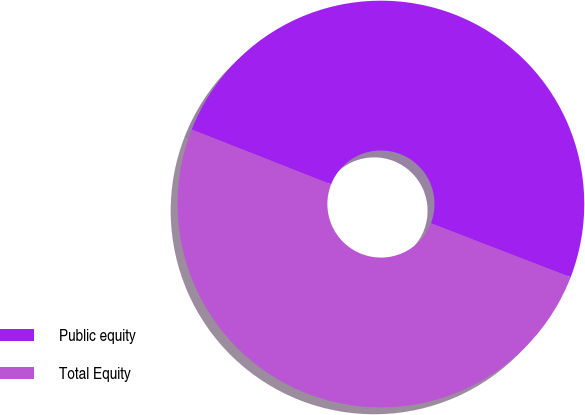Convert chart. <chart><loc_0><loc_0><loc_500><loc_500><pie_chart><fcel>Public equity<fcel>Total Equity<nl><fcel>49.9%<fcel>50.1%<nl></chart> 